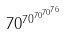<formula> <loc_0><loc_0><loc_500><loc_500>7 0 ^ { 7 0 ^ { 7 0 ^ { 7 0 ^ { 7 6 } } } }</formula> 